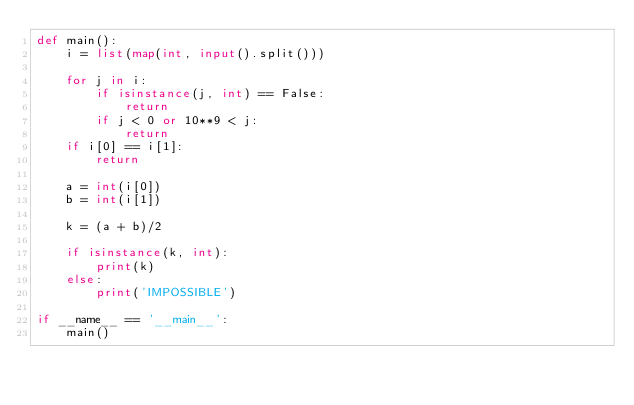<code> <loc_0><loc_0><loc_500><loc_500><_Python_>def main():
    i = list(map(int, input().split()))

    for j in i:
        if isinstance(j, int) == False:
            return
        if j < 0 or 10**9 < j:
            return
    if i[0] == i[1]:
        return

    a = int(i[0])
    b = int(i[1])

    k = (a + b)/2

    if isinstance(k, int):
        print(k)
    else:
        print('IMPOSSIBLE')

if __name__ == '__main__':
    main()</code> 